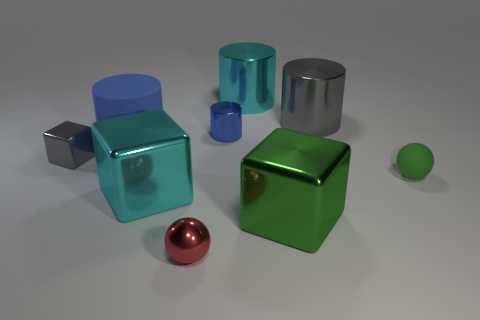How many objects are behind the green rubber object and right of the big green object?
Offer a terse response. 1. There is another ball that is the same size as the red shiny ball; what is its material?
Give a very brief answer. Rubber. Does the cube behind the large cyan metal block have the same size as the green thing on the right side of the gray metal cylinder?
Your answer should be compact. Yes. There is a large green metal object; are there any tiny blue objects to the right of it?
Your response must be concise. No. What is the color of the large metal block right of the blue cylinder that is behind the matte cylinder?
Offer a very short reply. Green. Is the number of cyan blocks less than the number of big yellow cylinders?
Make the answer very short. No. What number of small red objects have the same shape as the big blue thing?
Your answer should be compact. 0. What color is the other sphere that is the same size as the red metallic sphere?
Offer a very short reply. Green. Are there an equal number of blue matte cylinders that are to the right of the large blue cylinder and cyan shiny cylinders behind the small shiny ball?
Your answer should be very brief. No. Is there a yellow matte cylinder of the same size as the green metal cube?
Your response must be concise. No. 